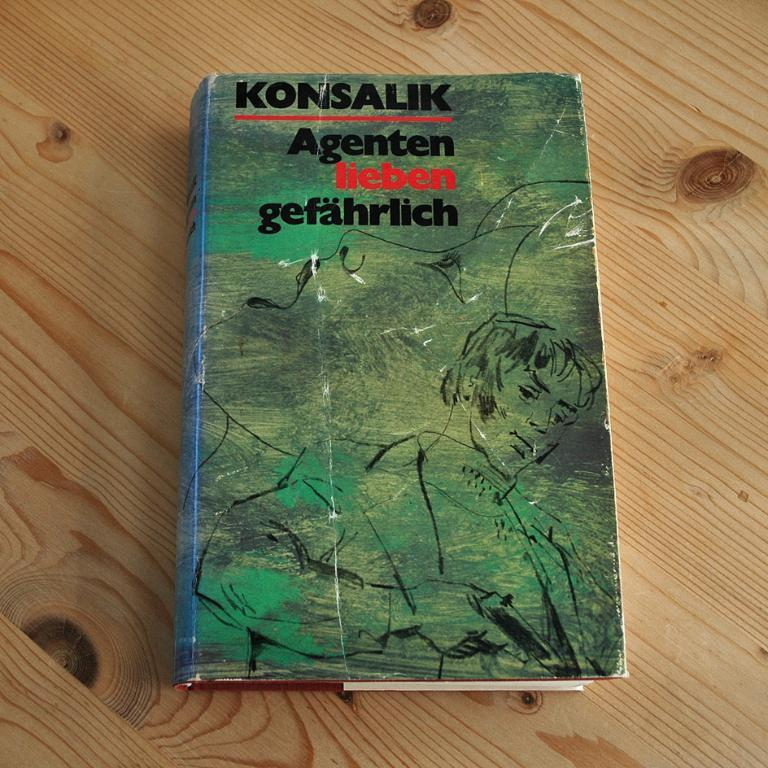Provide a one-sentence caption for the provided image. Konsalik Agenten lieben gefahrlich green and blue book. 